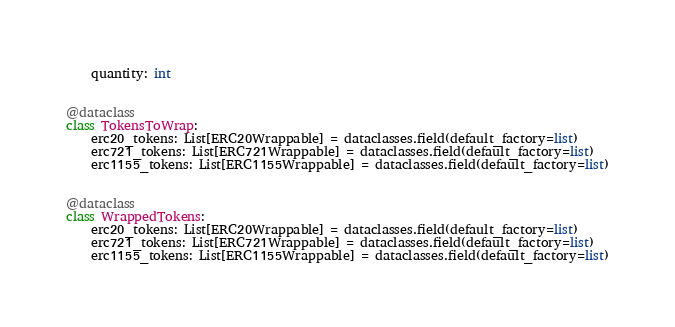Convert code to text. <code><loc_0><loc_0><loc_500><loc_500><_Python_>    quantity: int


@dataclass
class TokensToWrap:
    erc20_tokens: List[ERC20Wrappable] = dataclasses.field(default_factory=list)
    erc721_tokens: List[ERC721Wrappable] = dataclasses.field(default_factory=list)
    erc1155_tokens: List[ERC1155Wrappable] = dataclasses.field(default_factory=list)


@dataclass
class WrappedTokens:
    erc20_tokens: List[ERC20Wrappable] = dataclasses.field(default_factory=list)
    erc721_tokens: List[ERC721Wrappable] = dataclasses.field(default_factory=list)
    erc1155_tokens: List[ERC1155Wrappable] = dataclasses.field(default_factory=list)
</code> 